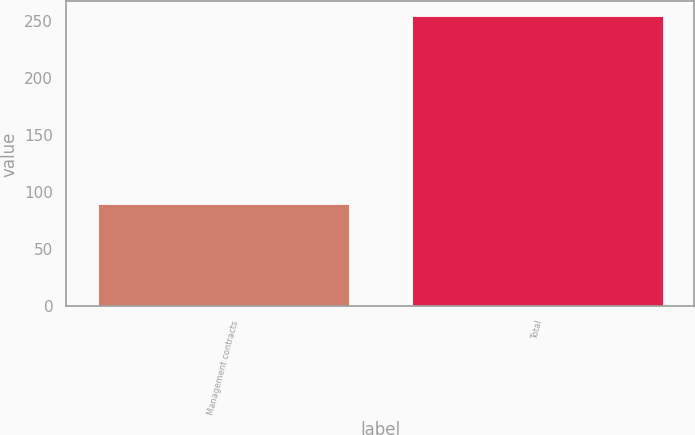Convert chart. <chart><loc_0><loc_0><loc_500><loc_500><bar_chart><fcel>Management contracts<fcel>Total<nl><fcel>89.5<fcel>254<nl></chart> 